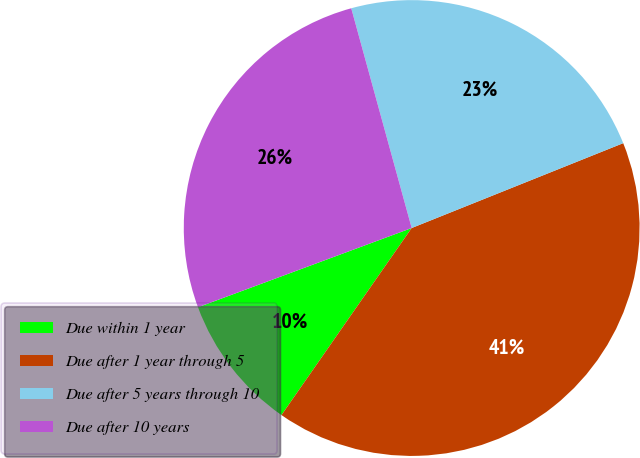Convert chart. <chart><loc_0><loc_0><loc_500><loc_500><pie_chart><fcel>Due within 1 year<fcel>Due after 1 year through 5<fcel>Due after 5 years through 10<fcel>Due after 10 years<nl><fcel>9.67%<fcel>40.75%<fcel>23.2%<fcel>26.38%<nl></chart> 